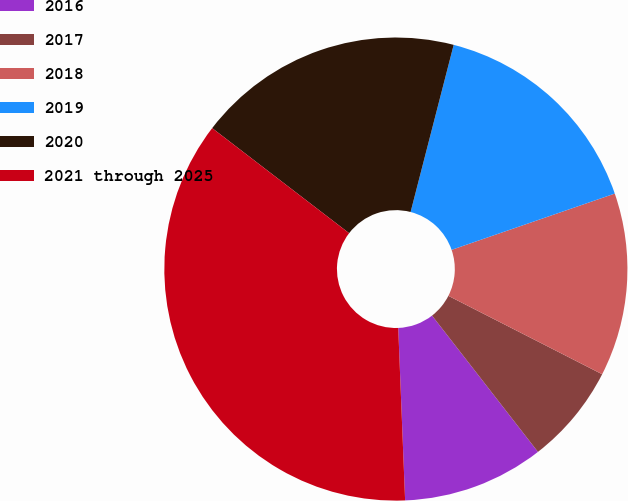<chart> <loc_0><loc_0><loc_500><loc_500><pie_chart><fcel>2016<fcel>2017<fcel>2018<fcel>2019<fcel>2020<fcel>2021 through 2025<nl><fcel>9.88%<fcel>6.98%<fcel>12.79%<fcel>15.7%<fcel>18.6%<fcel>36.05%<nl></chart> 